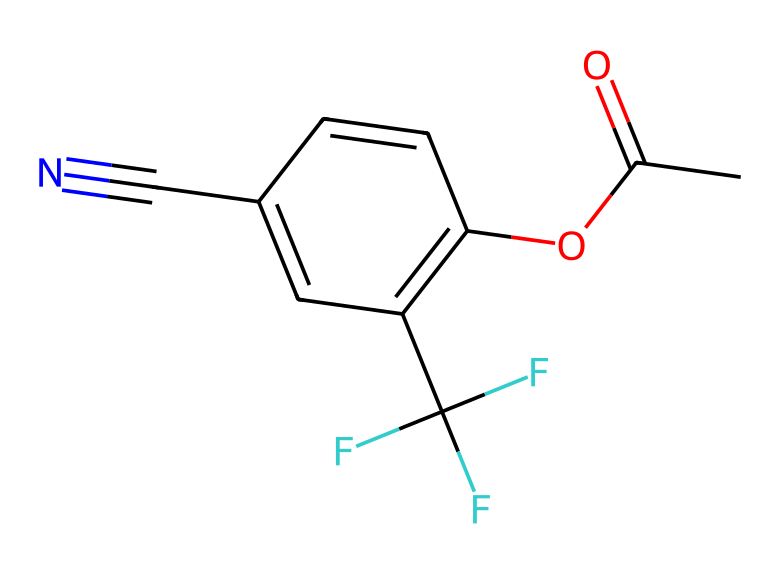What is the functional group present in this chemical? The chemical structure contains an ester group visible by the presence of the carbonyl group (C=O) adjacent to an oxygen atom that is bonded to another carbon atom (O-C).
Answer: ester How many carbon atoms are in this compound? By examining the SMILES representation, we can count all the carbon (C) atoms, which total to eight within the entire structure.
Answer: eight What does the presence of the trifluoromethyl group suggest about the acidity? The trifluoromethyl group (CF3) often increases the acidity of a compound due to the electronegative fluorine atoms, which stabilize the negative charge on the conjugate base after deprotonation.
Answer: increased acidity What is the overall hybridization of the central carbon atoms? Most carbon atoms in this structure are involved in either double bonds or single bonds, making them typically sp2 or sp3 hybridized. The carbon in the carbonyl (C=O) would be sp2 hybridized.
Answer: sp2 How does the presence of the cyano group influence the properties of this acid? The cyano group (C#N) is known to increase acidity; it can stabilize negative charge in the conjugate base through resonance, making the overall compound more acidic.
Answer: increases acidity 